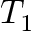<formula> <loc_0><loc_0><loc_500><loc_500>T _ { 1 }</formula> 